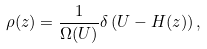<formula> <loc_0><loc_0><loc_500><loc_500>\rho ( z ) = \frac { 1 } { \Omega ( U ) } \delta \left ( U - H ( z ) \right ) ,</formula> 